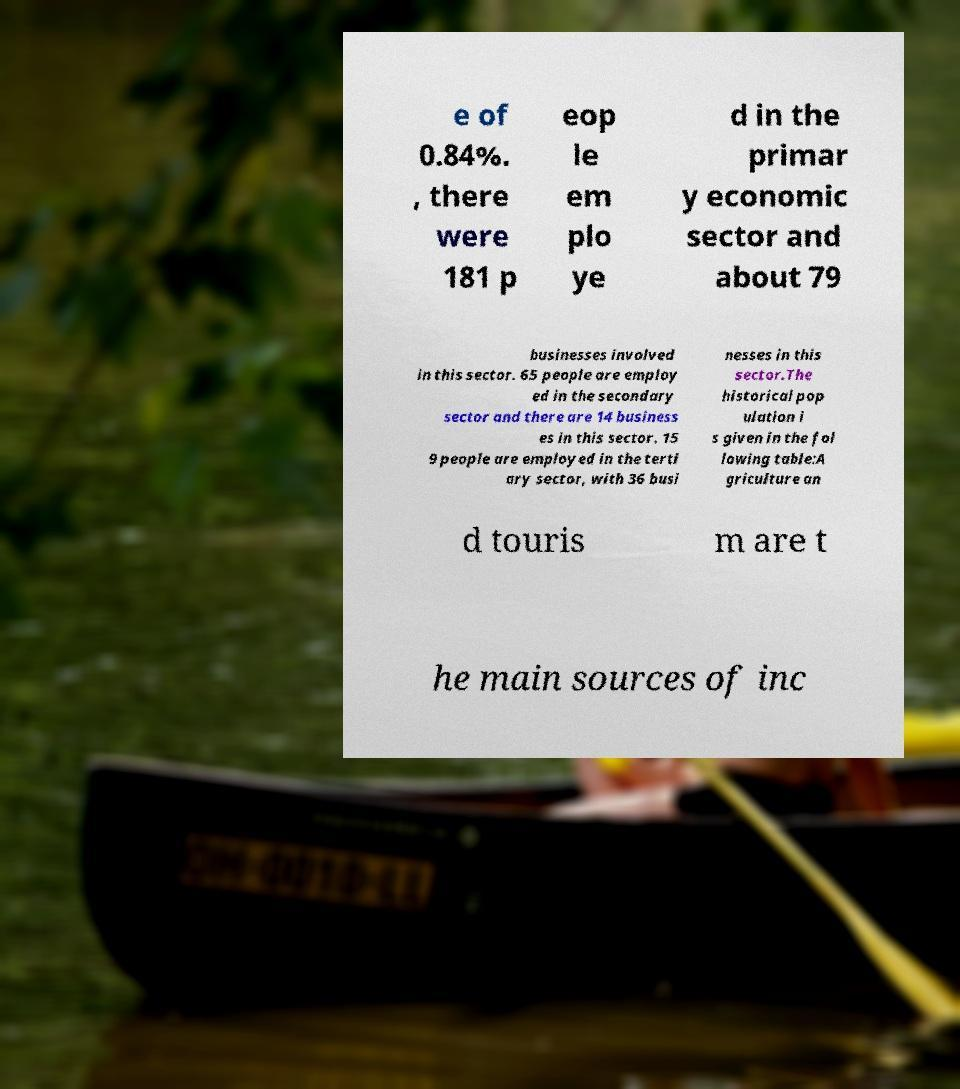There's text embedded in this image that I need extracted. Can you transcribe it verbatim? e of 0.84%. , there were 181 p eop le em plo ye d in the primar y economic sector and about 79 businesses involved in this sector. 65 people are employ ed in the secondary sector and there are 14 business es in this sector. 15 9 people are employed in the terti ary sector, with 36 busi nesses in this sector.The historical pop ulation i s given in the fol lowing table:A griculture an d touris m are t he main sources of inc 